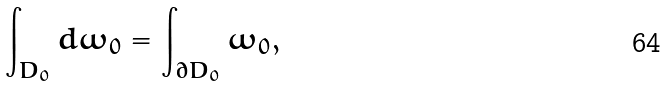Convert formula to latex. <formula><loc_0><loc_0><loc_500><loc_500>\int _ { D _ { 0 } } d \omega _ { 0 } = \int _ { \partial D _ { 0 } } \omega _ { 0 } ,</formula> 